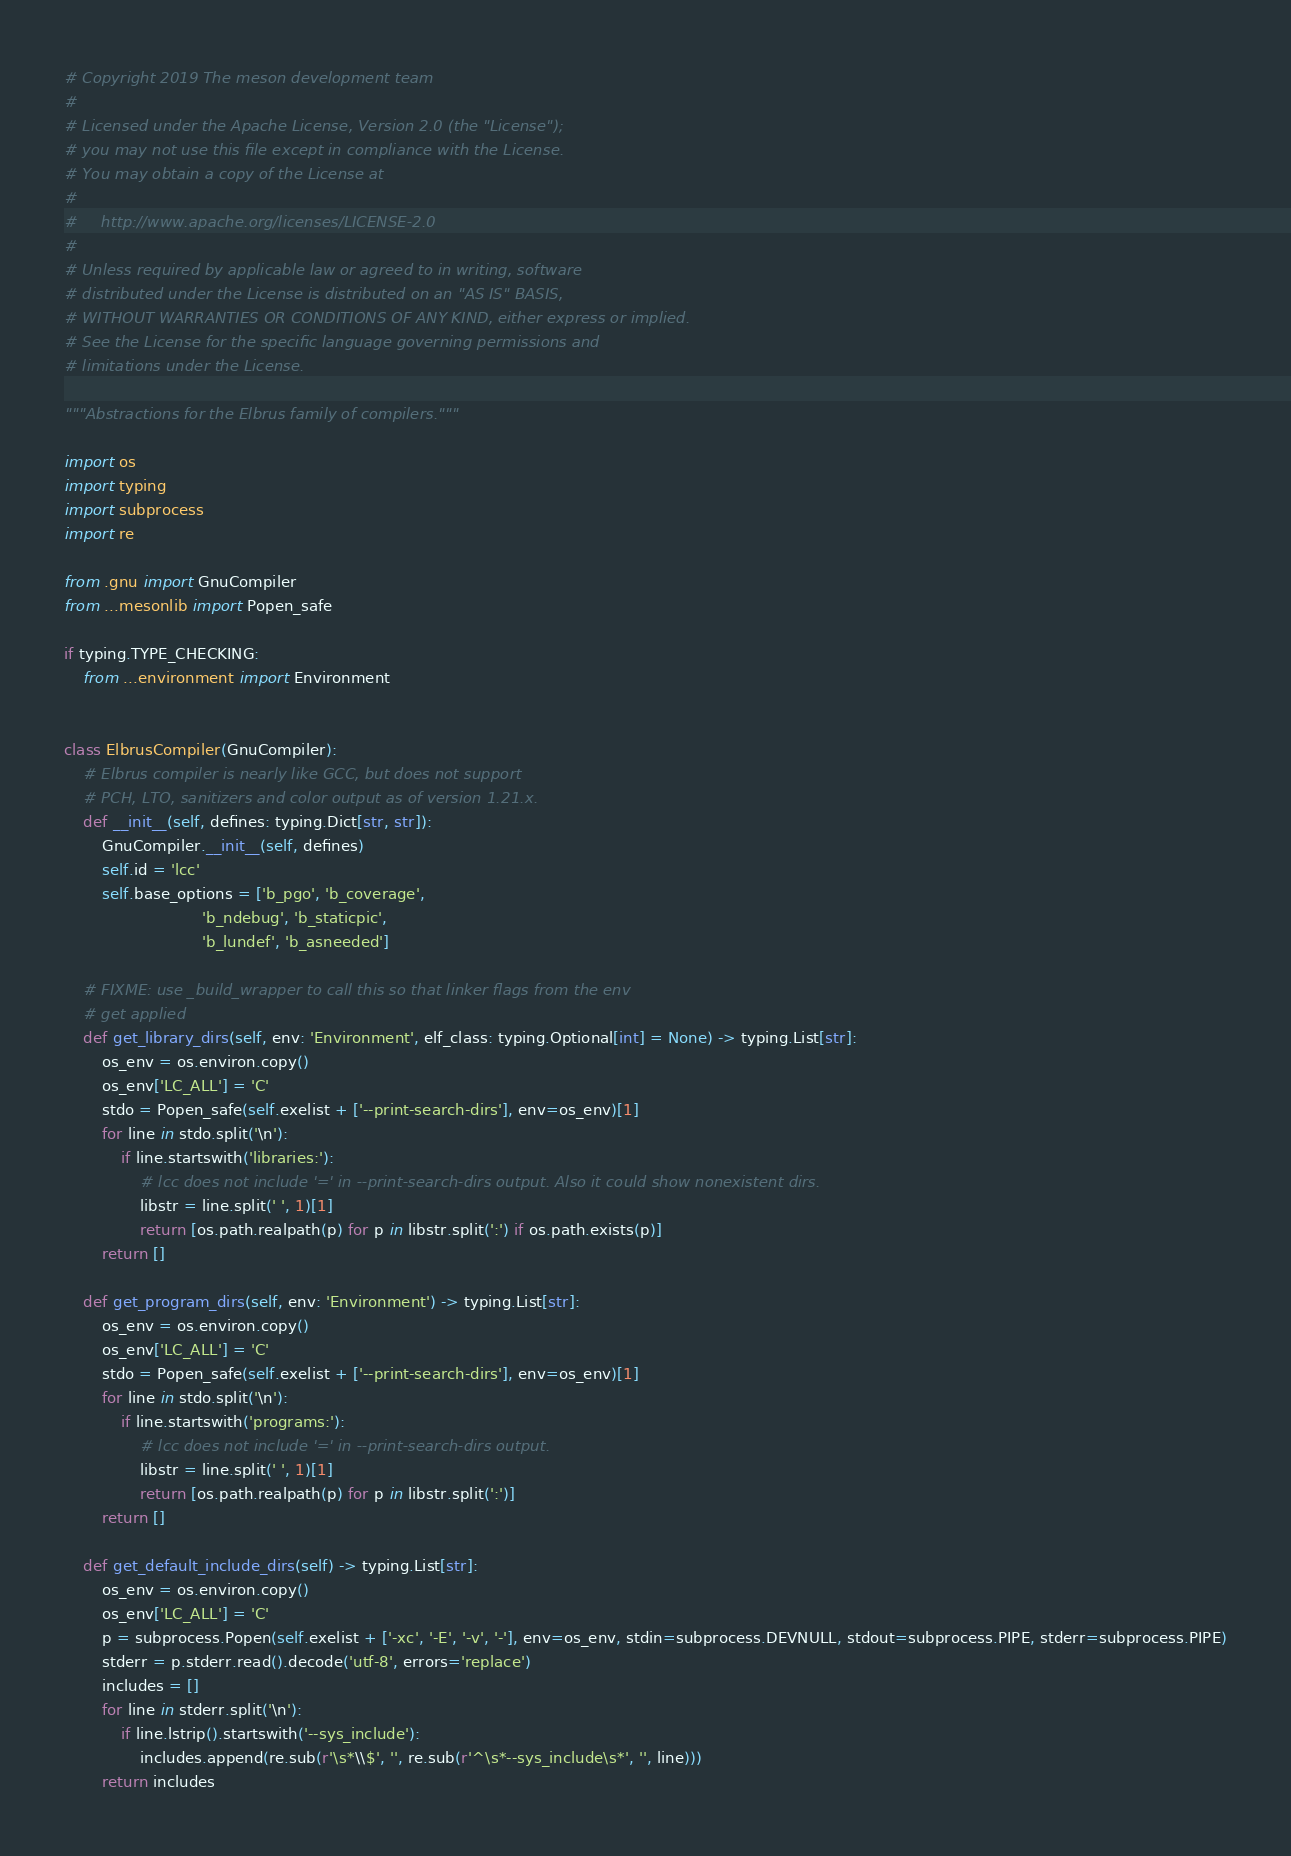<code> <loc_0><loc_0><loc_500><loc_500><_Python_># Copyright 2019 The meson development team
#
# Licensed under the Apache License, Version 2.0 (the "License");
# you may not use this file except in compliance with the License.
# You may obtain a copy of the License at
#
#     http://www.apache.org/licenses/LICENSE-2.0
#
# Unless required by applicable law or agreed to in writing, software
# distributed under the License is distributed on an "AS IS" BASIS,
# WITHOUT WARRANTIES OR CONDITIONS OF ANY KIND, either express or implied.
# See the License for the specific language governing permissions and
# limitations under the License.

"""Abstractions for the Elbrus family of compilers."""

import os
import typing
import subprocess
import re

from .gnu import GnuCompiler
from ...mesonlib import Popen_safe

if typing.TYPE_CHECKING:
    from ...environment import Environment


class ElbrusCompiler(GnuCompiler):
    # Elbrus compiler is nearly like GCC, but does not support
    # PCH, LTO, sanitizers and color output as of version 1.21.x.
    def __init__(self, defines: typing.Dict[str, str]):
        GnuCompiler.__init__(self, defines)
        self.id = 'lcc'
        self.base_options = ['b_pgo', 'b_coverage',
                             'b_ndebug', 'b_staticpic',
                             'b_lundef', 'b_asneeded']

    # FIXME: use _build_wrapper to call this so that linker flags from the env
    # get applied
    def get_library_dirs(self, env: 'Environment', elf_class: typing.Optional[int] = None) -> typing.List[str]:
        os_env = os.environ.copy()
        os_env['LC_ALL'] = 'C'
        stdo = Popen_safe(self.exelist + ['--print-search-dirs'], env=os_env)[1]
        for line in stdo.split('\n'):
            if line.startswith('libraries:'):
                # lcc does not include '=' in --print-search-dirs output. Also it could show nonexistent dirs.
                libstr = line.split(' ', 1)[1]
                return [os.path.realpath(p) for p in libstr.split(':') if os.path.exists(p)]
        return []

    def get_program_dirs(self, env: 'Environment') -> typing.List[str]:
        os_env = os.environ.copy()
        os_env['LC_ALL'] = 'C'
        stdo = Popen_safe(self.exelist + ['--print-search-dirs'], env=os_env)[1]
        for line in stdo.split('\n'):
            if line.startswith('programs:'):
                # lcc does not include '=' in --print-search-dirs output.
                libstr = line.split(' ', 1)[1]
                return [os.path.realpath(p) for p in libstr.split(':')]
        return []

    def get_default_include_dirs(self) -> typing.List[str]:
        os_env = os.environ.copy()
        os_env['LC_ALL'] = 'C'
        p = subprocess.Popen(self.exelist + ['-xc', '-E', '-v', '-'], env=os_env, stdin=subprocess.DEVNULL, stdout=subprocess.PIPE, stderr=subprocess.PIPE)
        stderr = p.stderr.read().decode('utf-8', errors='replace')
        includes = []
        for line in stderr.split('\n'):
            if line.lstrip().startswith('--sys_include'):
                includes.append(re.sub(r'\s*\\$', '', re.sub(r'^\s*--sys_include\s*', '', line)))
        return includes
</code> 